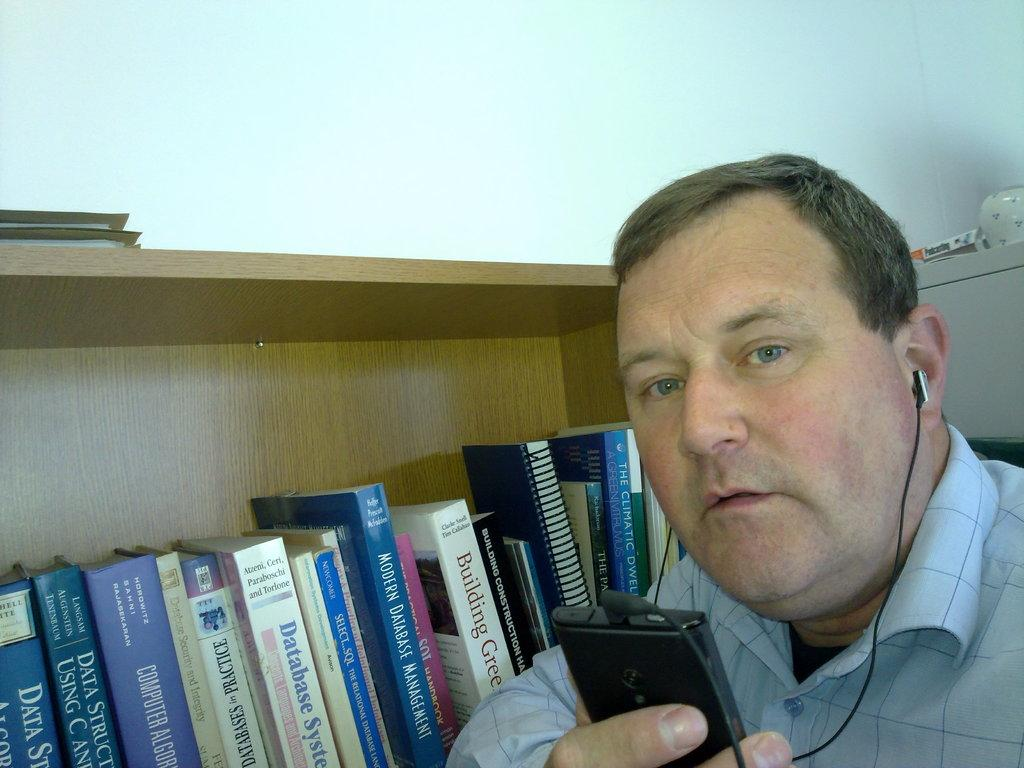<image>
Offer a succinct explanation of the picture presented. A man checks his phone while standing next to a bookcase filled with information about data, database systems, and database security. 